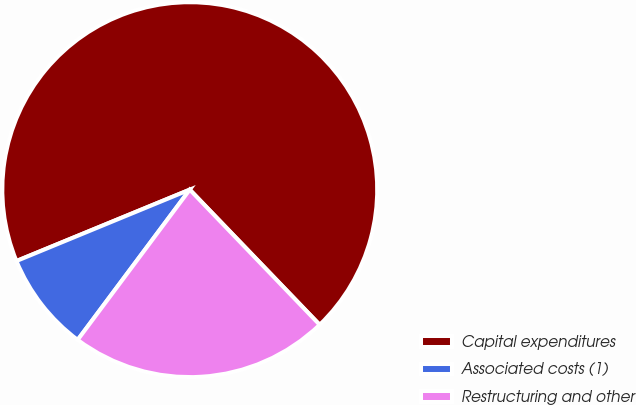Convert chart to OTSL. <chart><loc_0><loc_0><loc_500><loc_500><pie_chart><fcel>Capital expenditures<fcel>Associated costs (1)<fcel>Restructuring and other<nl><fcel>69.03%<fcel>8.58%<fcel>22.39%<nl></chart> 